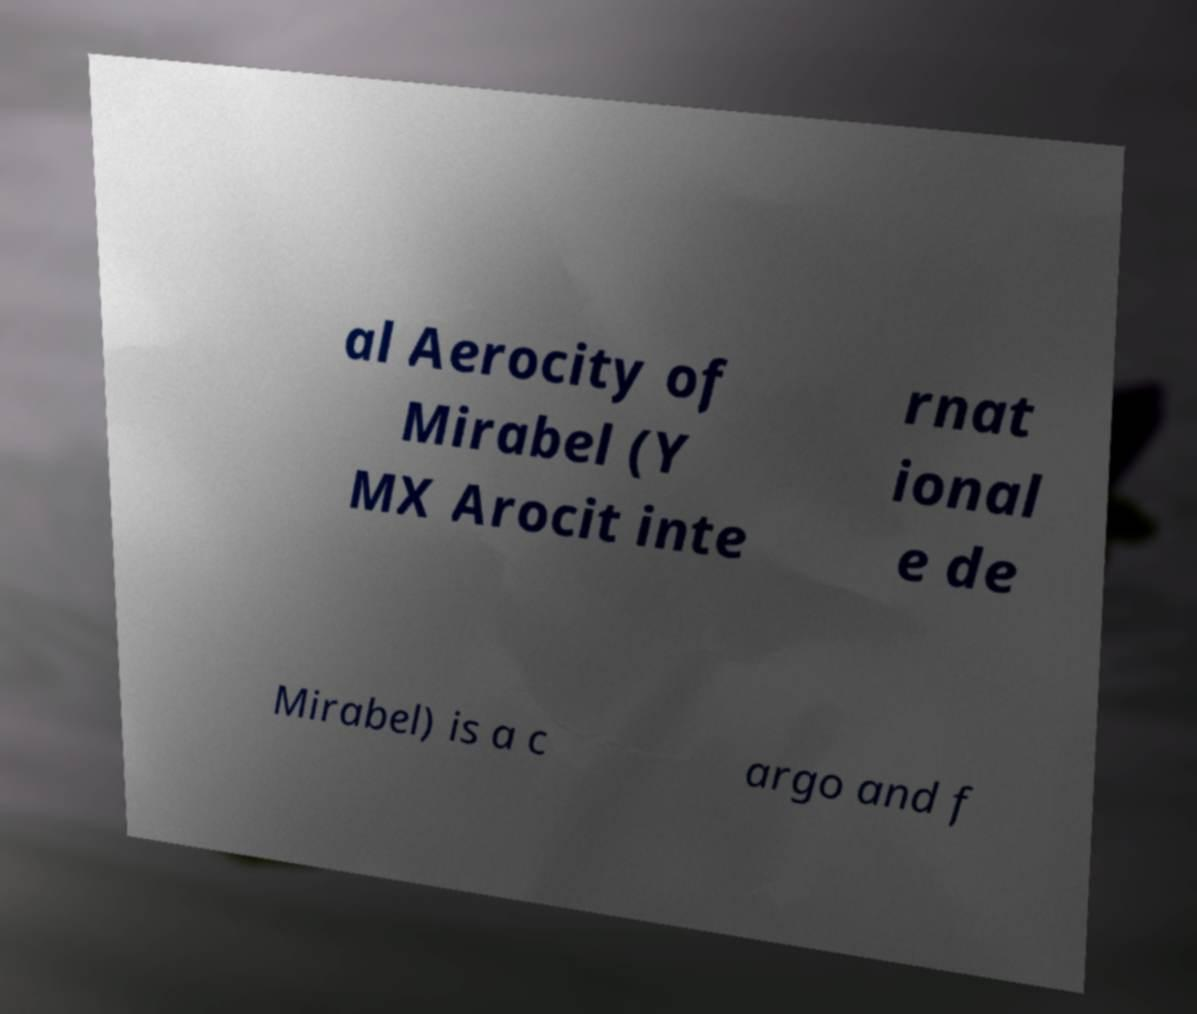What messages or text are displayed in this image? I need them in a readable, typed format. al Aerocity of Mirabel (Y MX Arocit inte rnat ional e de Mirabel) is a c argo and f 